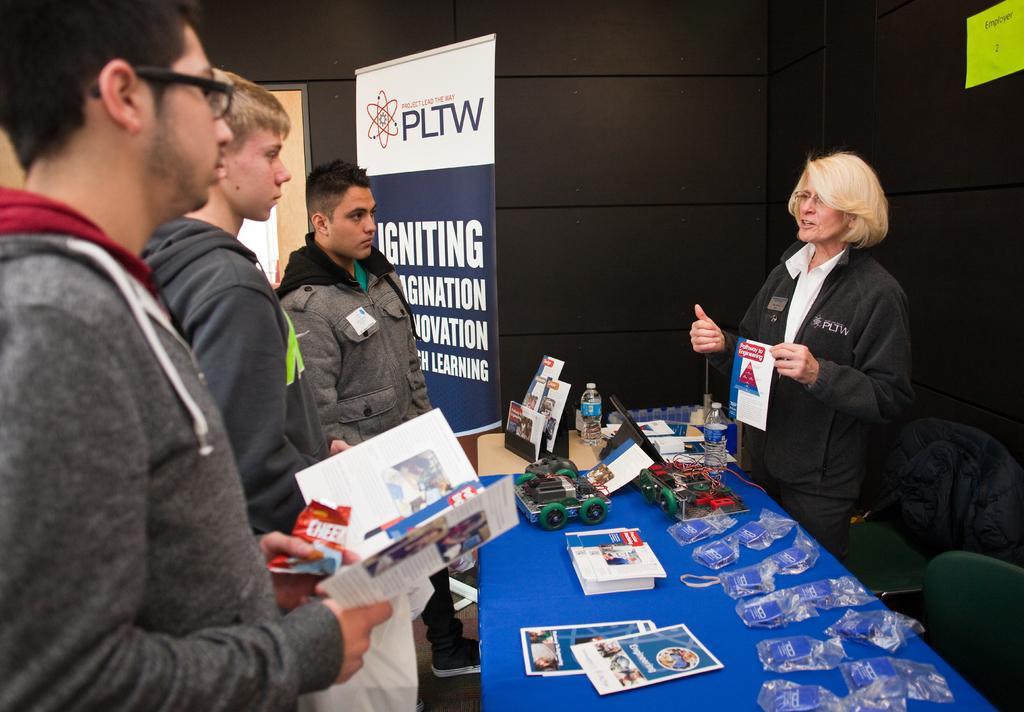Could you give a brief overview of what you see in this image? On the right side of this image I can see a woman wearing black color jacket, standing and speaking something by looking at the people who are standing in front of her. She is holding a white color paper in her hand. The three men who are standing on the left side are wearing jackets and holding some papers in their hands and looking at this woman. In front of this woman there is a table which is covered with a blue color cloth. On this I can see some papers, packets, bottles, toys, wires and some more objects. Beside the table there are two empty chairs. In the background, I can see the wall and also there is a board. 